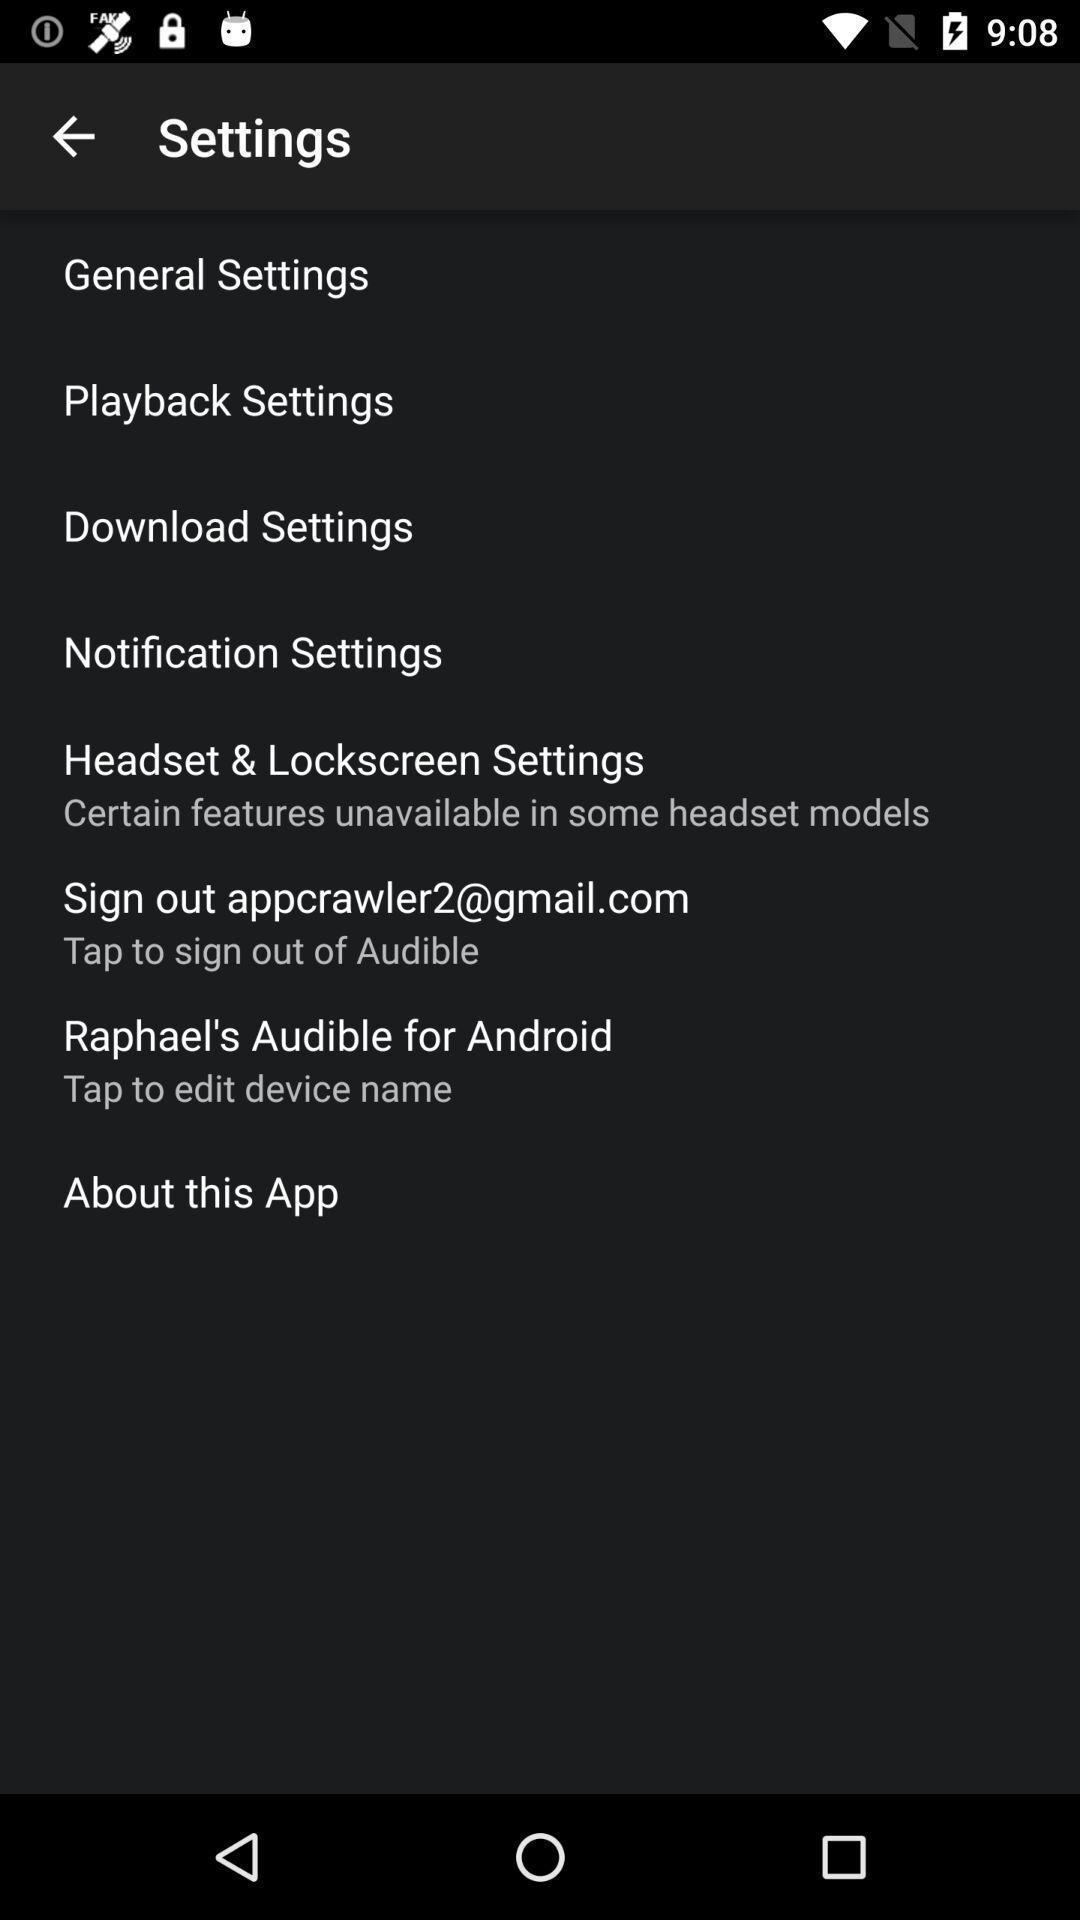Provide a textual representation of this image. Page displaying with list of different settings. 